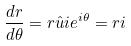Convert formula to latex. <formula><loc_0><loc_0><loc_500><loc_500>\frac { d r } { d \theta } = r \hat { u } i e ^ { i \theta } = r i</formula> 